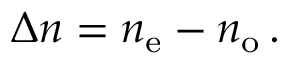<formula> <loc_0><loc_0><loc_500><loc_500>\Delta n = n _ { e } - n _ { o } \, .</formula> 